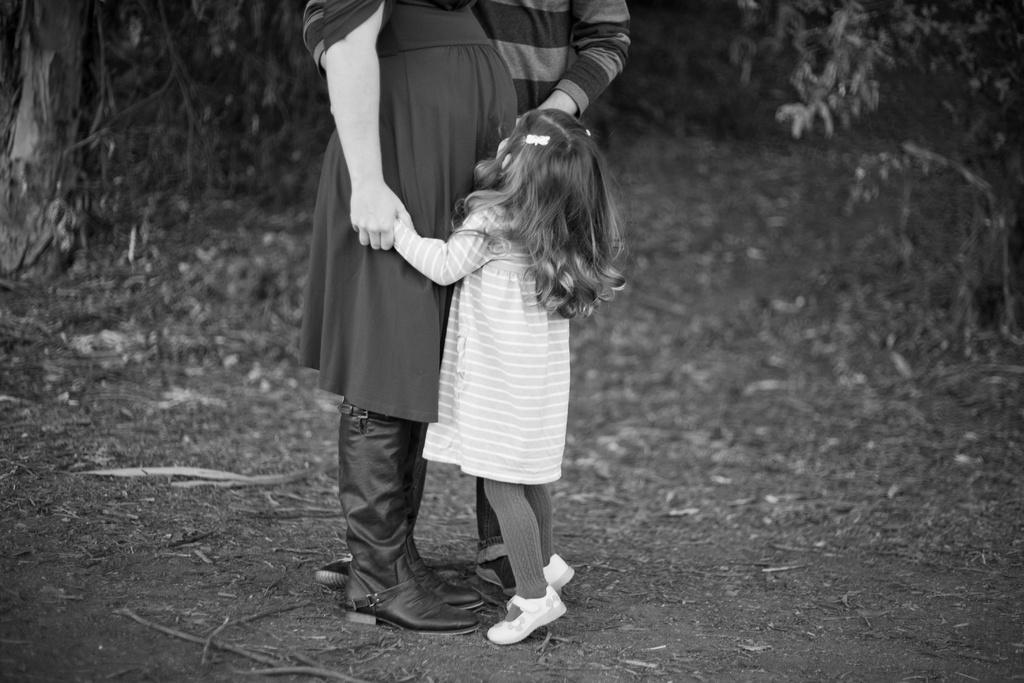How many people are present in the image? There are two persons and a kid standing in the image. What is present at the bottom of the image? There are leaves at the bottom of the image. What can be seen in the background of the image? There are trees in the background of the image. What is the color scheme of the image? The image is black and white. What type of card is the ghost holding in the image? There is no ghost or card present in the image. 